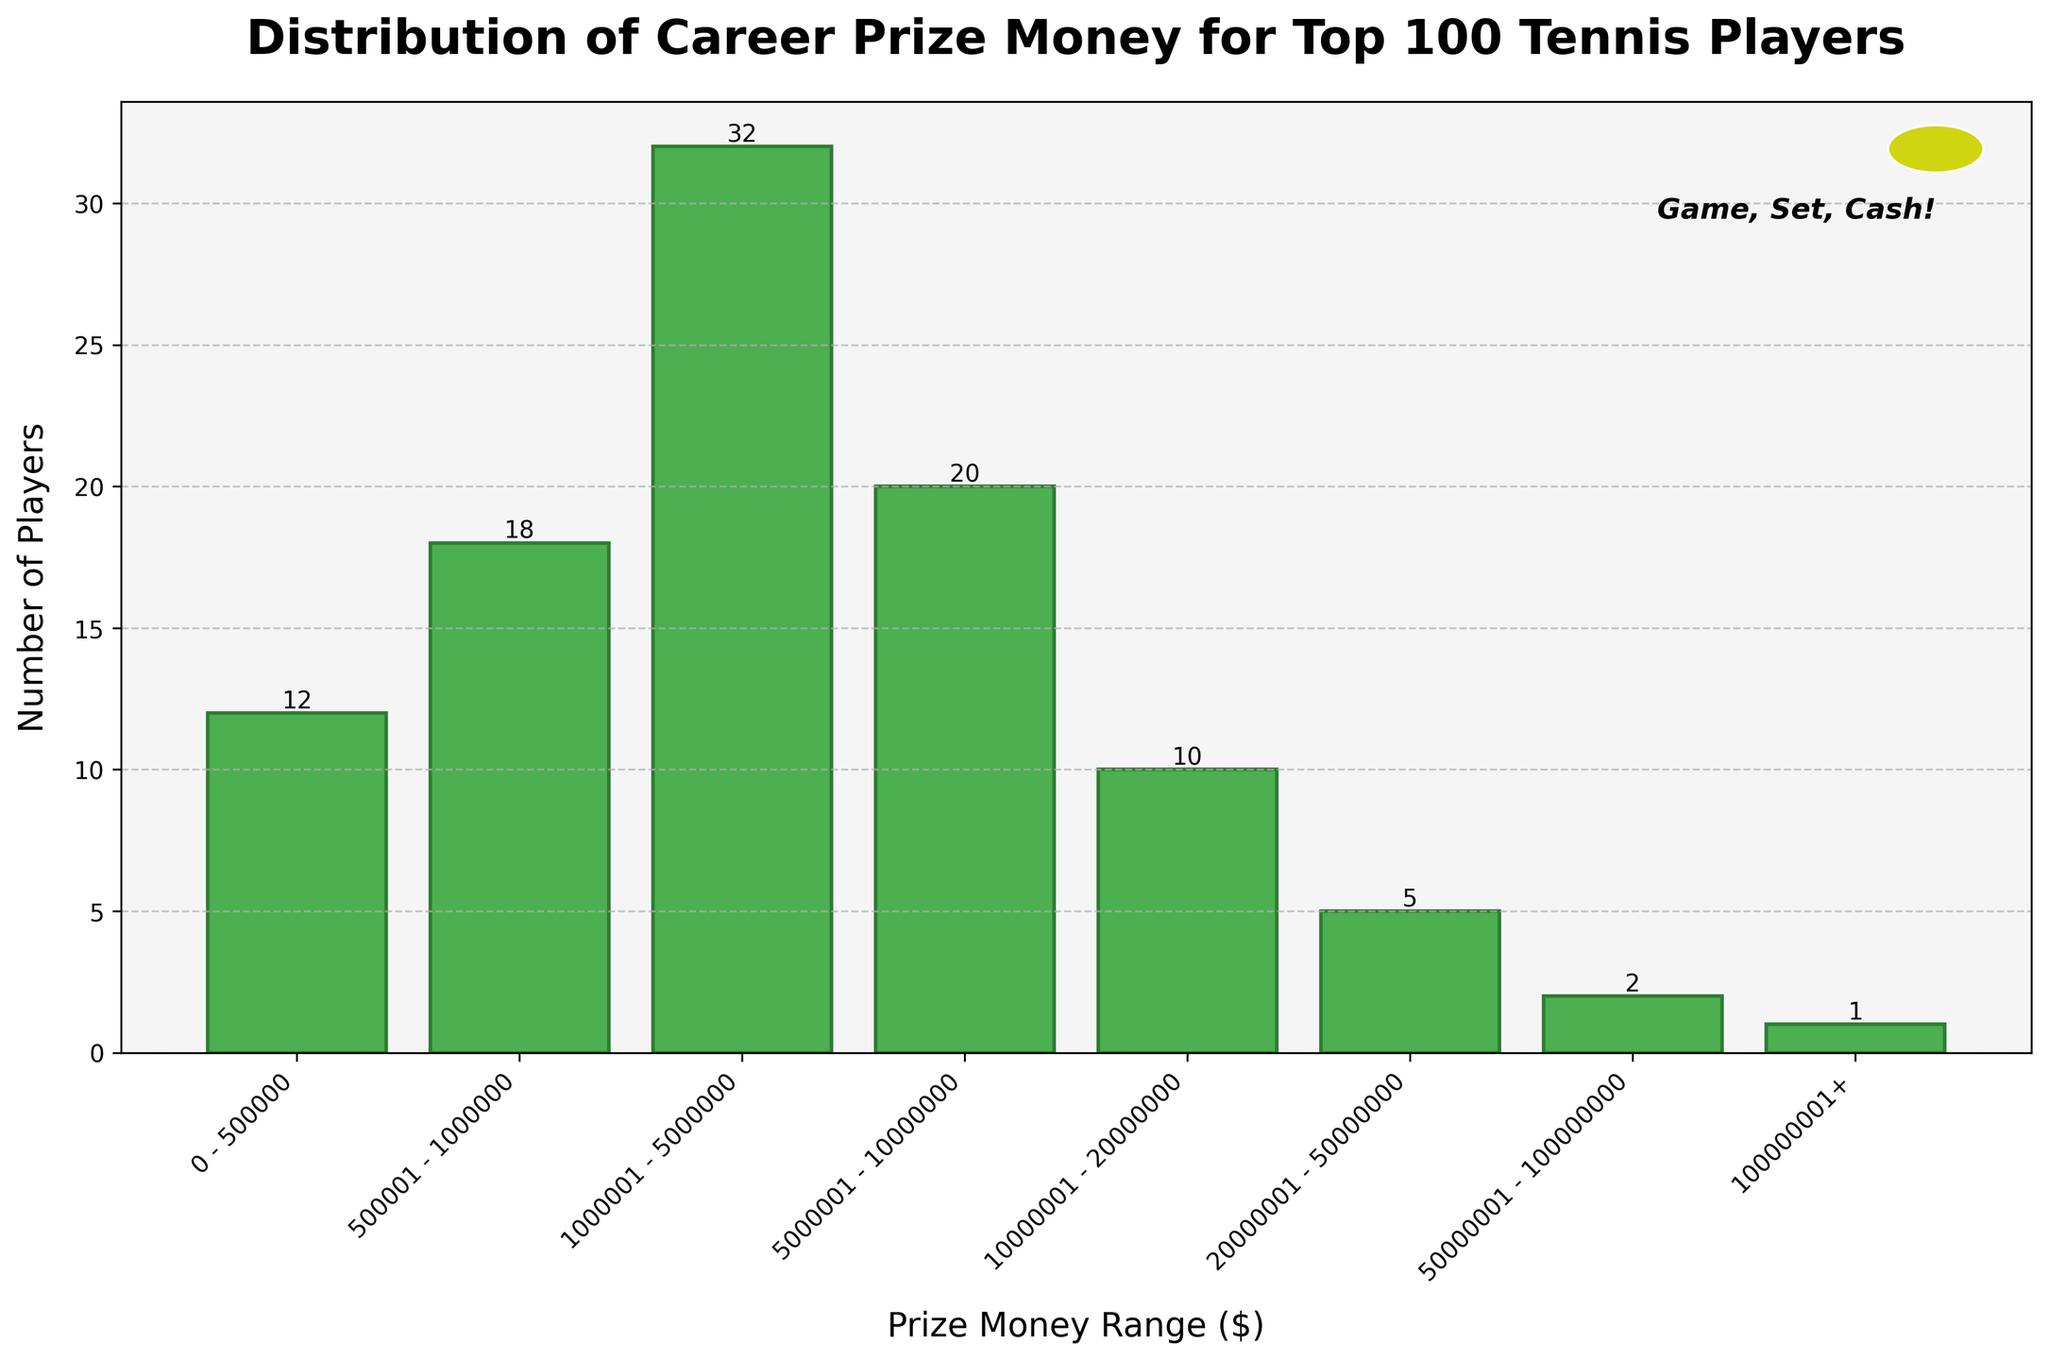How many players have earned between $1,000,001 and $5,000,000 in prize money? The histogram shows the distribution of players' prize money by different ranges. Looking at the bin labeled "$1,000,001 - $5,000,000", it has a bar extending to the value 32 on the y-axis, which represents the number of players.
Answer: 32 Which prize money range has the fewest number of players? By observing the height of the bars on the histogram, the bin labeled "$100,000,001+" has the shortest bar, indicating that this range has the fewest number of players, which is exactly 1.
Answer: $100,000,001+ What is the total number of players with career earnings less than $1,000,001? To find the total, sum the players in the ranges "0 - $500,000" and "$500,001 - $1,000,000". These bins contain 12 and 18 players respectively, so 12 + 18 = 30 players.
Answer: 30 How many players have earned more than $20,000,000 in their career? By adding up the players in the bins "$20,000,001 - $50,000,000", "$50,000,001 - $100,000,000", and "$100,000,001+", we get 5 + 2 + 1 = 8 players.
Answer: 8 Which prize money range contains the most players? The range "$1,000,001 - $5,000,000" has the highest bar on the histogram, indicating it contains the most players, which is 32 in number.
Answer: $1,000,001 - $5,000,000 Comparing the ranges "$500,001 - $1,000,000" and "$500,000,001 - $100,000,000," which one has more players and by how many? The histogram shows that "$500,001 - $1,000,000" has 18 players while $50,000,001 - $100,000,000" has 2 players. The difference is 18 - 2 = 16 players.
Answer: $500,001 - $1,000,000, by 16 players What is the average number of players per prize money range? To find the average, sum up the number of players in each range and divide by the number of ranges. The sum is 12 + 18 + 32 + 20 + 10 + 5 + 2 + 1 = 100. There are 8 ranges, so the average is 100 / 8 = 12.5 players.
Answer: 12.5 players What percentage of the top 100 players have earned between $5,000,001 and $50,000,000? Add the number of players in the ranges "$5,000,001 - $10,000,000" and "$20,000,001 - $50,000,000". This gives 20 + 5 = 25 players. To find the percentage, (25 / 100) * 100 = 25%.
Answer: 25% 